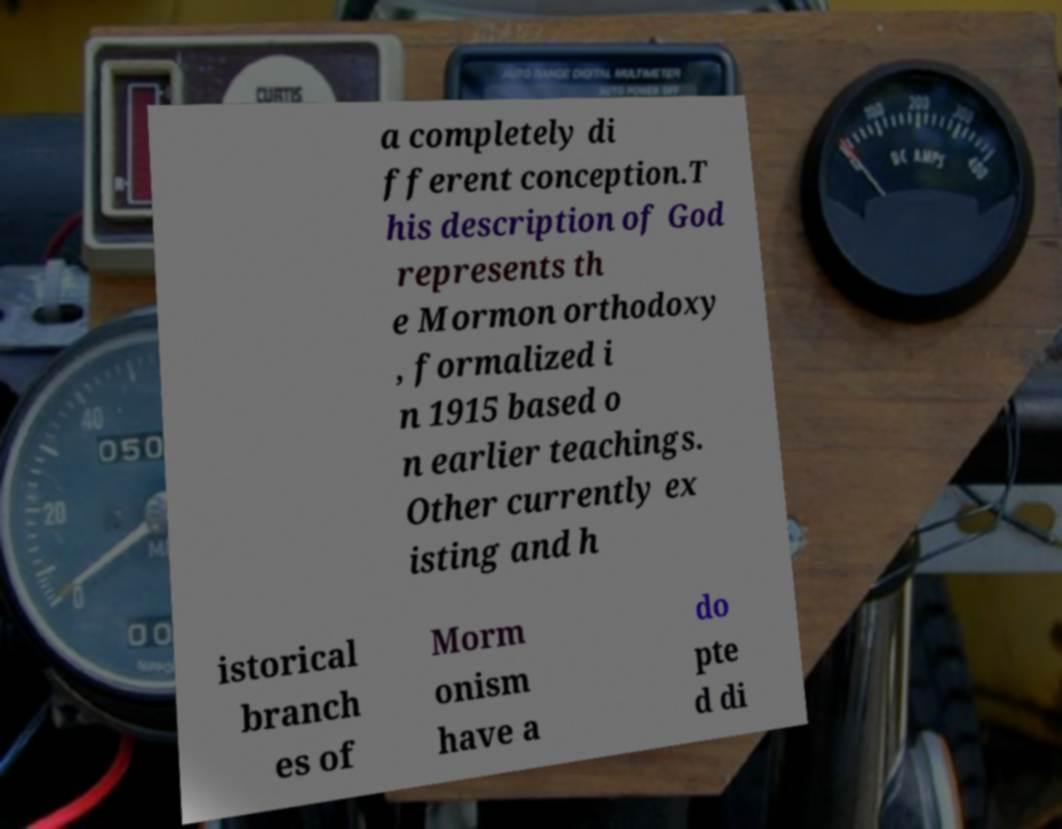For documentation purposes, I need the text within this image transcribed. Could you provide that? a completely di fferent conception.T his description of God represents th e Mormon orthodoxy , formalized i n 1915 based o n earlier teachings. Other currently ex isting and h istorical branch es of Morm onism have a do pte d di 